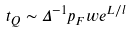Convert formula to latex. <formula><loc_0><loc_0><loc_500><loc_500>t _ { Q } \sim \Delta ^ { - 1 } p _ { F } w e ^ { L / l }</formula> 